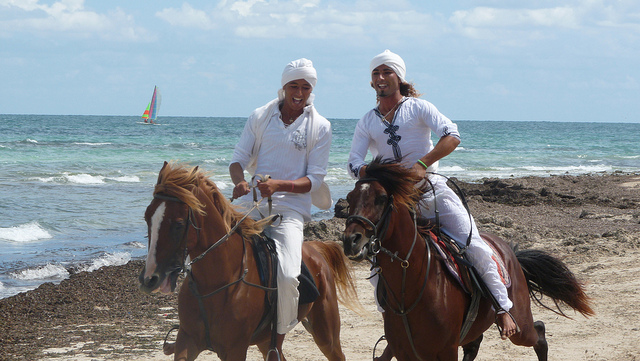Imagine they found a treasure map. What happens next? Upon finding the treasure map, excitement fills the air. They decide to embark on an adventure, riding their horses along the coastline and into the hidden trails as the map directs. Each clue leads them closer to a mysterious treasure buried by pirates long ago, with suspense and camaraderie growing every step of the way. What if they encounter a mysterious stranger during their quest for the treasure? During their treasure hunt, they cross paths with a mysterious stranger who warns them of the dangers ahead. Intrigued but cautious, they decide to heed his advice while continuing their quest. The stranger offers them cryptic clues and helps them navigate treacherous pathways, leading to an unexpected alliance and ensuring their adventure is thrilling and filled with unexpected turns. How would this adventure change their lives? This adventure would be a life-changing experience for them. Not only would it deepen their friendship, but it would also instill a sense of courage and resilience. The challenges they face and overcome together would create memories to cherish for a lifetime, teaching them about trust, teamwork, and the thrill of embarking on extraordinary endeavors. The treasure, if found, could alter their material lives, providing new opportunities and a unique tale to tell for generations. Describe a scenario where they decided to return to this beach after many years. What might they feel and experience? Returning to the beach after many years, they are enveloped by a wave of nostalgia. Riding along the familiar shore, they reminisce about their past adventure, the laughter, and the bond they shared. The beach, largely unchanged, serves as a time capsule, reigniting old memories. They feel a deep sense of fulfillment and joy as they recount their treasure hunt, the challenges faced, and the mysterious stranger's guidance. It’s a bittersweet moment — happy to relive the past but also reflective on the passage of time, the changes in their lives, and the enduring friendship that withstood it all. As they dismount and walk along the beach, they find remnants of their old adventure: perhaps a buried trinket or a note left behind years ago. This discovery sparks a renewed sense of wonder and the realization that adventures, whether past or present, continue to shape and inspire them. They leave the beach with renewed spirits, promising to seek out new adventures together, no matter where life takes them. 